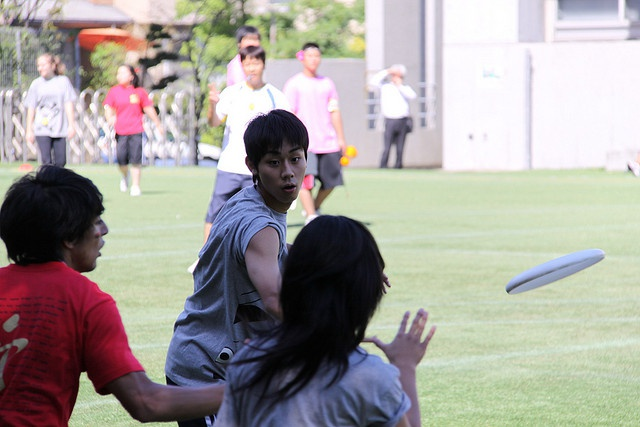Describe the objects in this image and their specific colors. I can see people in tan, black, maroon, gray, and brown tones, people in tan, black, and gray tones, people in tan, black, and gray tones, people in tan, white, darkgray, and lightpink tones, and people in tan, lavender, gray, lightpink, and violet tones in this image. 